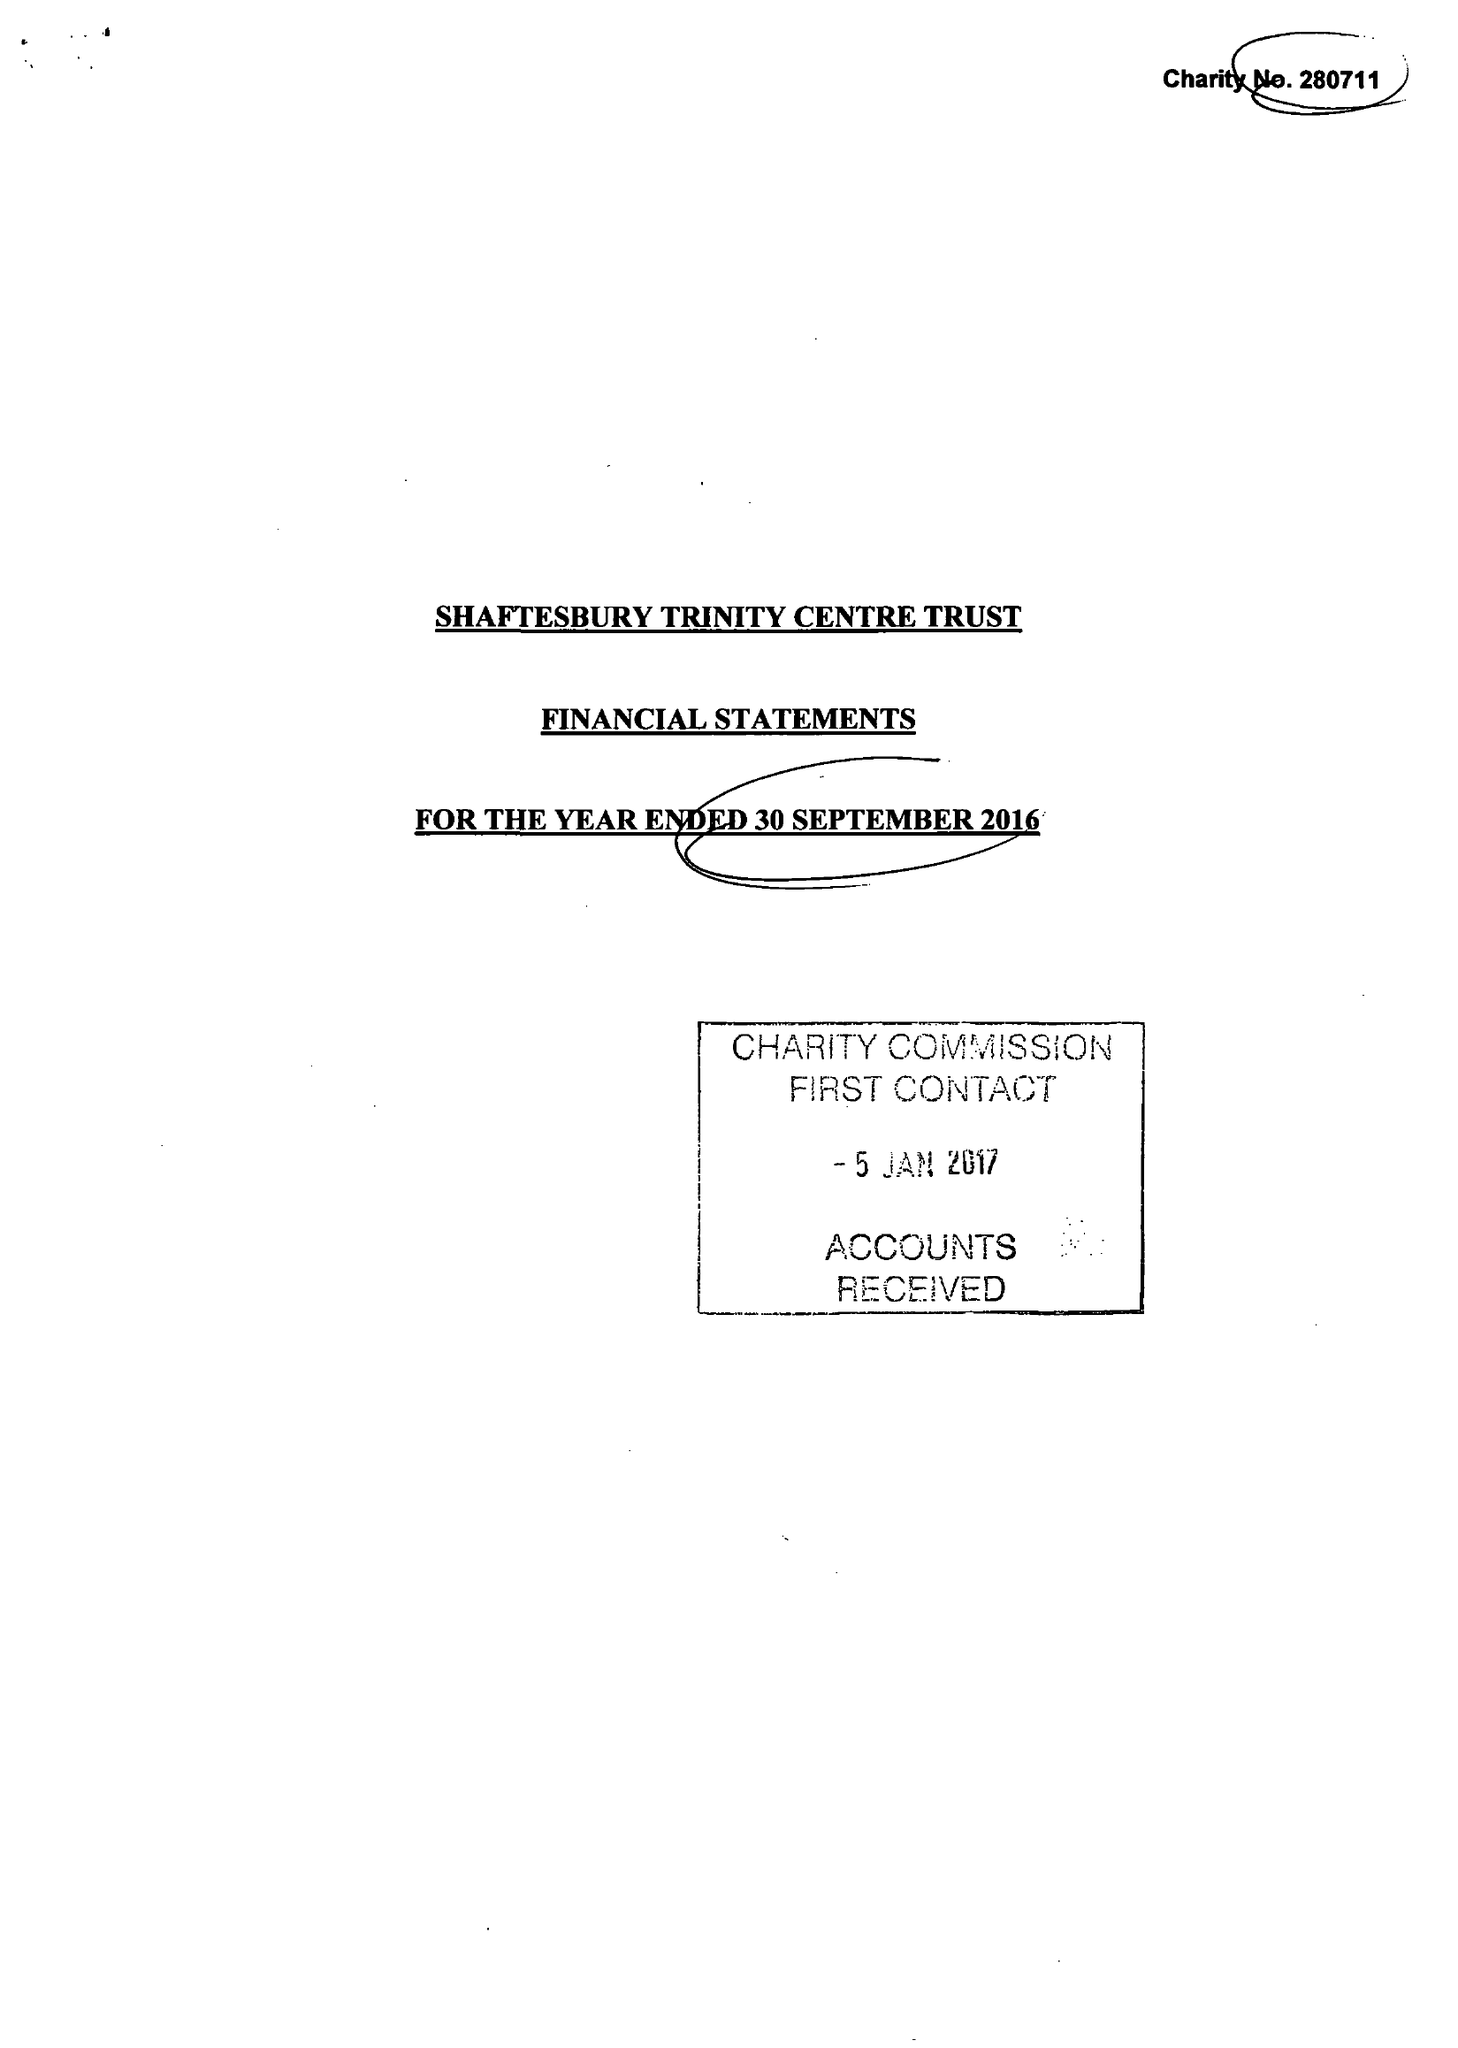What is the value for the report_date?
Answer the question using a single word or phrase. 2016-09-30 